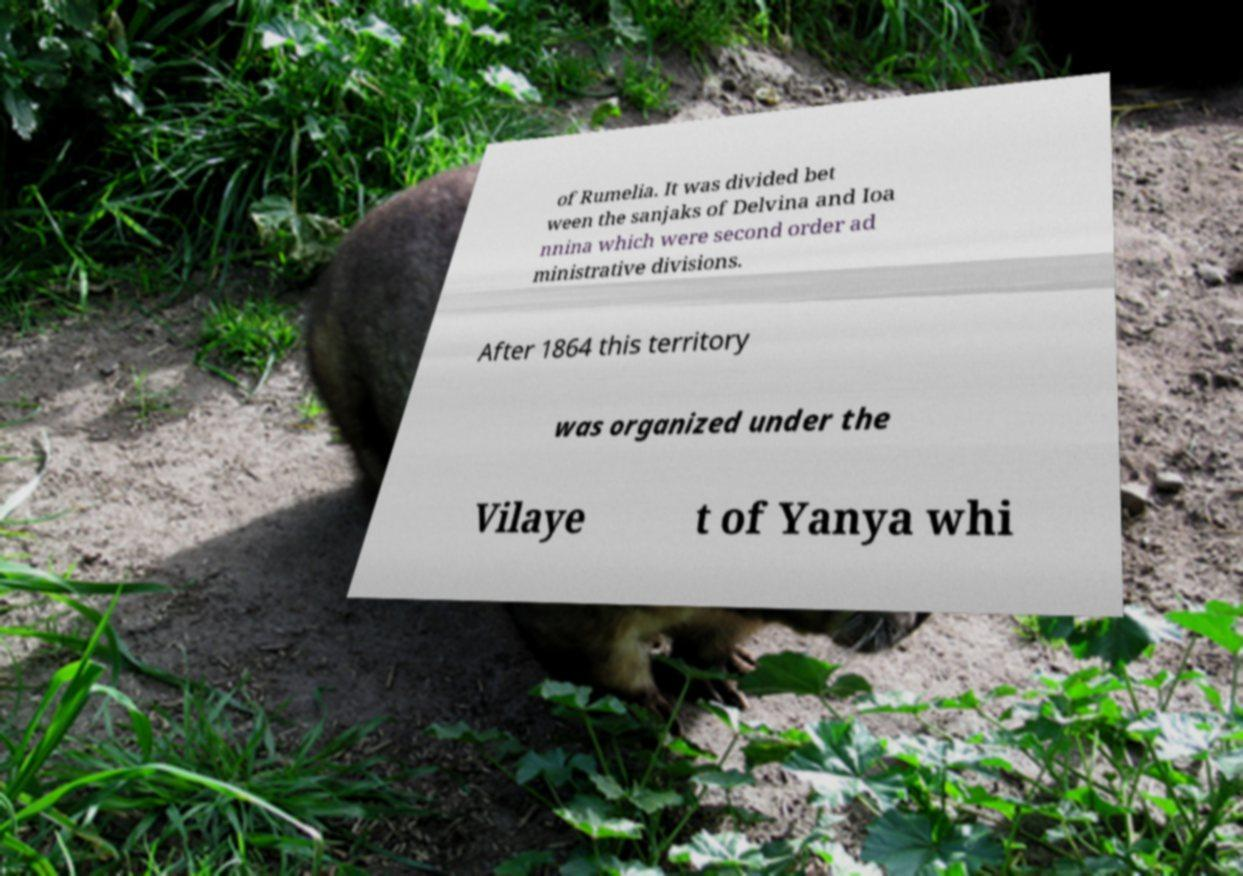Can you read and provide the text displayed in the image?This photo seems to have some interesting text. Can you extract and type it out for me? of Rumelia. It was divided bet ween the sanjaks of Delvina and Ioa nnina which were second order ad ministrative divisions. After 1864 this territory was organized under the Vilaye t of Yanya whi 